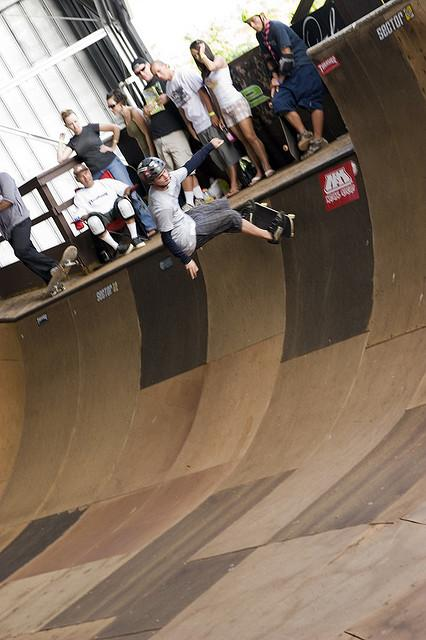What is the man skateboarding on? Please explain your reasoning. half pipe. The skating surface curves sharply upward at least at one end of it, and is roughly the height of an adult person at its highest point. 